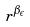Convert formula to latex. <formula><loc_0><loc_0><loc_500><loc_500>r ^ { \beta _ { \epsilon } }</formula> 